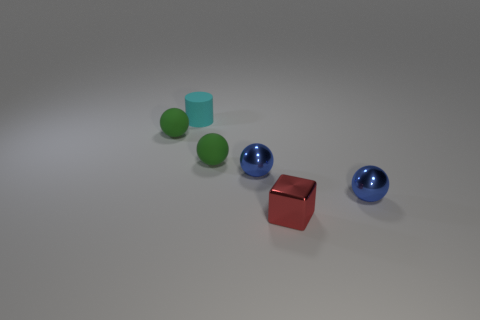Subtract 2 balls. How many balls are left? 2 Subtract all cyan spheres. Subtract all green cylinders. How many spheres are left? 4 Add 3 small metal objects. How many objects exist? 9 Subtract all spheres. How many objects are left? 2 Subtract all shiny things. Subtract all cyan matte things. How many objects are left? 2 Add 2 rubber balls. How many rubber balls are left? 4 Add 3 small cylinders. How many small cylinders exist? 4 Subtract 0 yellow cylinders. How many objects are left? 6 